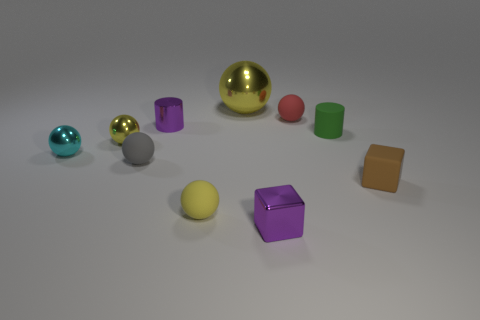How many yellow balls must be subtracted to get 1 yellow balls? 2 Subtract 2 cylinders. How many cylinders are left? 0 Subtract all green balls. Subtract all purple cylinders. How many balls are left? 6 Subtract all brown cylinders. How many red balls are left? 1 Subtract all tiny green matte things. Subtract all matte spheres. How many objects are left? 6 Add 9 brown matte cubes. How many brown matte cubes are left? 10 Add 6 purple metal objects. How many purple metal objects exist? 8 Subtract all purple blocks. How many blocks are left? 1 Subtract all large yellow balls. How many balls are left? 5 Subtract 1 purple blocks. How many objects are left? 9 